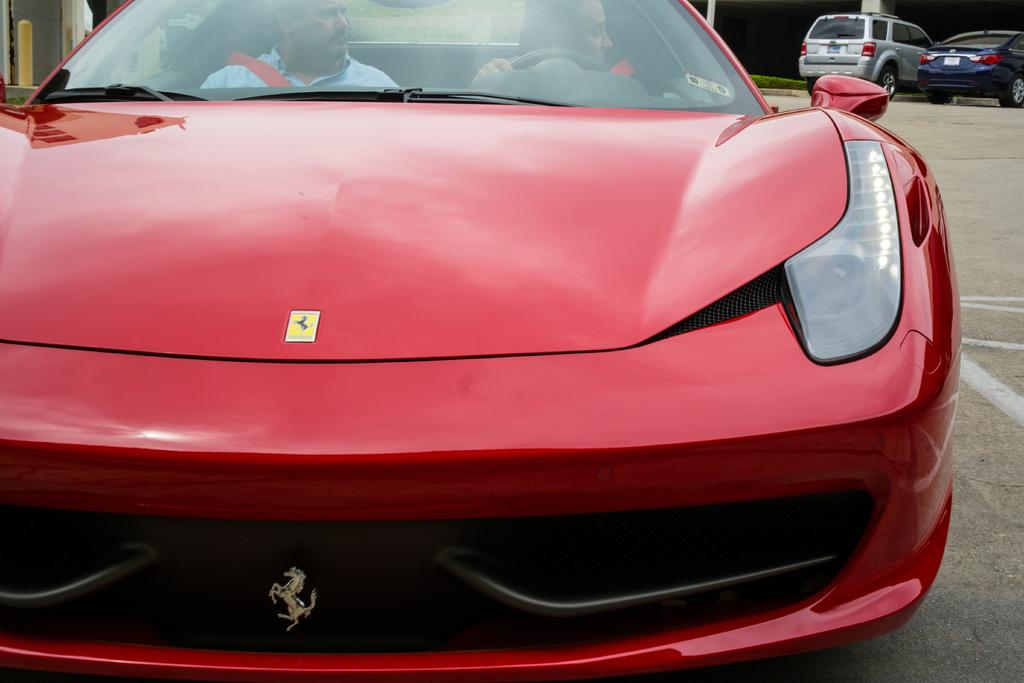What can be seen on the road in the image? There are cars on the road in the image. Can you describe the occupants of one of the cars? Two persons are sitting in a red car. What type of vegetation is visible in the image? There is grass visible in the image. What type of spy equipment can be seen in the image? There is no spy equipment present in the image. What type of stew is being cooked in the image? There is no stew being cooked in the image. 